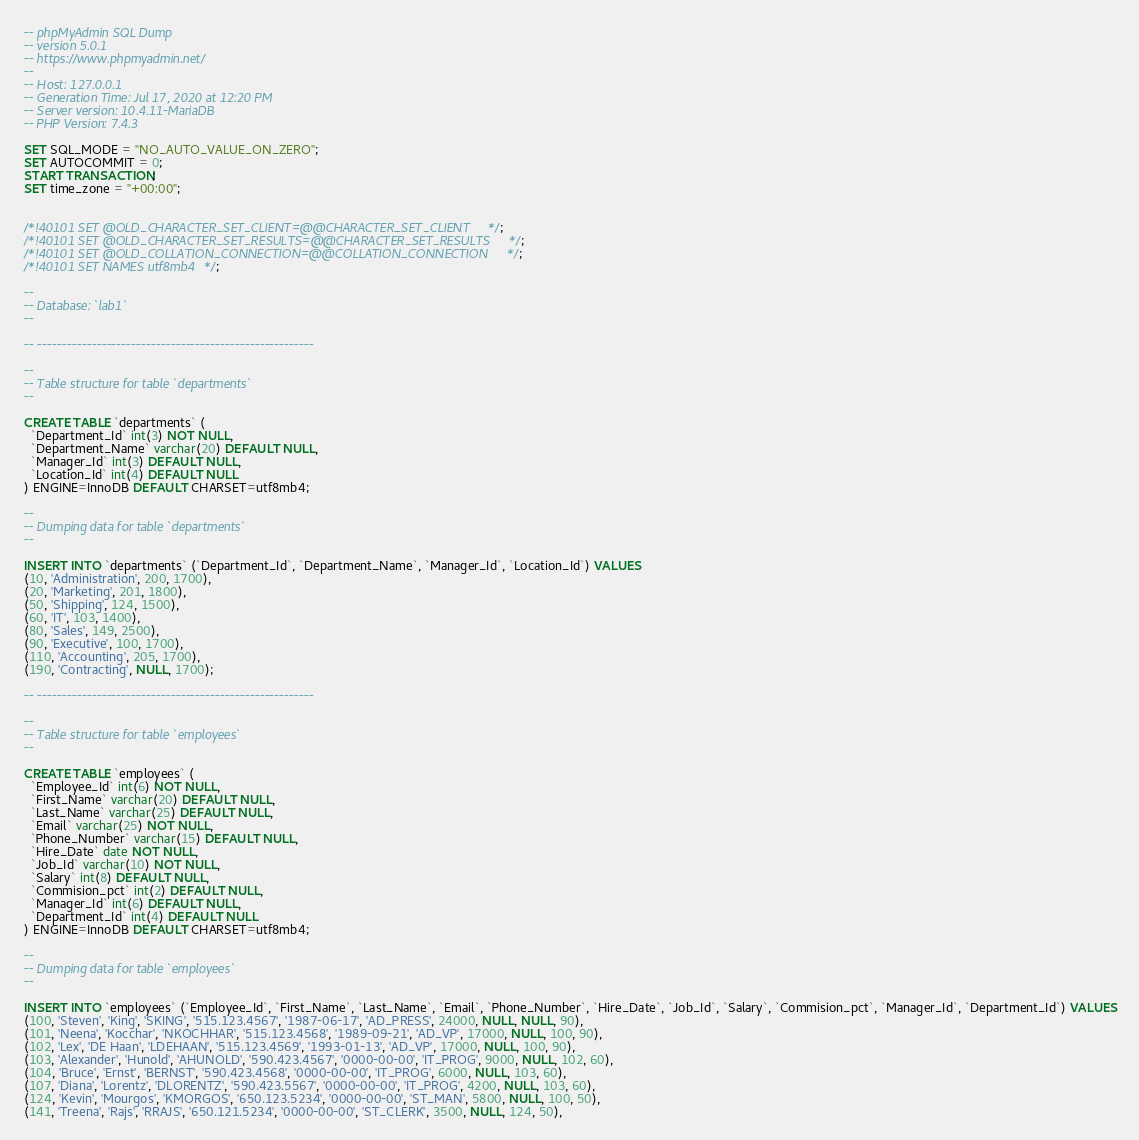<code> <loc_0><loc_0><loc_500><loc_500><_SQL_>-- phpMyAdmin SQL Dump
-- version 5.0.1
-- https://www.phpmyadmin.net/
--
-- Host: 127.0.0.1
-- Generation Time: Jul 17, 2020 at 12:20 PM
-- Server version: 10.4.11-MariaDB
-- PHP Version: 7.4.3

SET SQL_MODE = "NO_AUTO_VALUE_ON_ZERO";
SET AUTOCOMMIT = 0;
START TRANSACTION;
SET time_zone = "+00:00";


/*!40101 SET @OLD_CHARACTER_SET_CLIENT=@@CHARACTER_SET_CLIENT */;
/*!40101 SET @OLD_CHARACTER_SET_RESULTS=@@CHARACTER_SET_RESULTS */;
/*!40101 SET @OLD_COLLATION_CONNECTION=@@COLLATION_CONNECTION */;
/*!40101 SET NAMES utf8mb4 */;

--
-- Database: `lab1`
--

-- --------------------------------------------------------

--
-- Table structure for table `departments`
--

CREATE TABLE `departments` (
  `Department_Id` int(3) NOT NULL,
  `Department_Name` varchar(20) DEFAULT NULL,
  `Manager_Id` int(3) DEFAULT NULL,
  `Location_Id` int(4) DEFAULT NULL
) ENGINE=InnoDB DEFAULT CHARSET=utf8mb4;

--
-- Dumping data for table `departments`
--

INSERT INTO `departments` (`Department_Id`, `Department_Name`, `Manager_Id`, `Location_Id`) VALUES
(10, 'Administration', 200, 1700),
(20, 'Marketing', 201, 1800),
(50, 'Shipping', 124, 1500),
(60, 'IT', 103, 1400),
(80, 'Sales', 149, 2500),
(90, 'Executive', 100, 1700),
(110, 'Accounting', 205, 1700),
(190, 'Contracting', NULL, 1700);

-- --------------------------------------------------------

--
-- Table structure for table `employees`
--

CREATE TABLE `employees` (
  `Employee_Id` int(6) NOT NULL,
  `First_Name` varchar(20) DEFAULT NULL,
  `Last_Name` varchar(25) DEFAULT NULL,
  `Email` varchar(25) NOT NULL,
  `Phone_Number` varchar(15) DEFAULT NULL,
  `Hire_Date` date NOT NULL,
  `Job_Id` varchar(10) NOT NULL,
  `Salary` int(8) DEFAULT NULL,
  `Commision_pct` int(2) DEFAULT NULL,
  `Manager_Id` int(6) DEFAULT NULL,
  `Department_Id` int(4) DEFAULT NULL
) ENGINE=InnoDB DEFAULT CHARSET=utf8mb4;

--
-- Dumping data for table `employees`
--

INSERT INTO `employees` (`Employee_Id`, `First_Name`, `Last_Name`, `Email`, `Phone_Number`, `Hire_Date`, `Job_Id`, `Salary`, `Commision_pct`, `Manager_Id`, `Department_Id`) VALUES
(100, 'Steven', 'King', 'SKING', '515.123.4567', '1987-06-17', 'AD_PRESS', 24000, NULL, NULL, 90),
(101, 'Neena', 'Kocchar', 'NKOCHHAR', '515.123.4568', '1989-09-21', 'AD_VP', 17000, NULL, 100, 90),
(102, 'Lex', 'DE Haan', 'LDEHAAN', '515.123.4569', '1993-01-13', 'AD_VP', 17000, NULL, 100, 90),
(103, 'Alexander', 'Hunold', 'AHUNOLD', '590.423.4567', '0000-00-00', 'IT_PROG', 9000, NULL, 102, 60),
(104, 'Bruce', 'Ernst', 'BERNST', '590.423.4568', '0000-00-00', 'IT_PROG', 6000, NULL, 103, 60),
(107, 'Diana', 'Lorentz', 'DLORENTZ', '590.423.5567', '0000-00-00', 'IT_PROG', 4200, NULL, 103, 60),
(124, 'Kevin', 'Mourgos', 'KMORGOS', '650.123.5234', '0000-00-00', 'ST_MAN', 5800, NULL, 100, 50),
(141, 'Treena', 'Rajs', 'RRAJS', '650.121.5234', '0000-00-00', 'ST_CLERK', 3500, NULL, 124, 50),</code> 